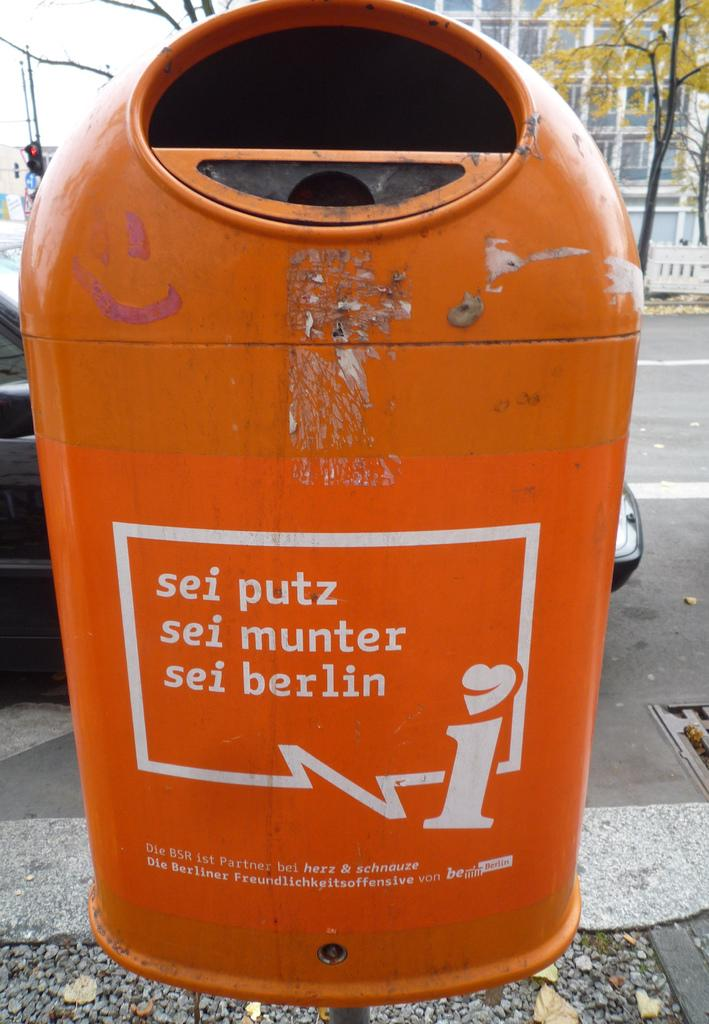<image>
Write a terse but informative summary of the picture. An orange trashcan on a sidewalk says sei putz sei munter sei berlin. 